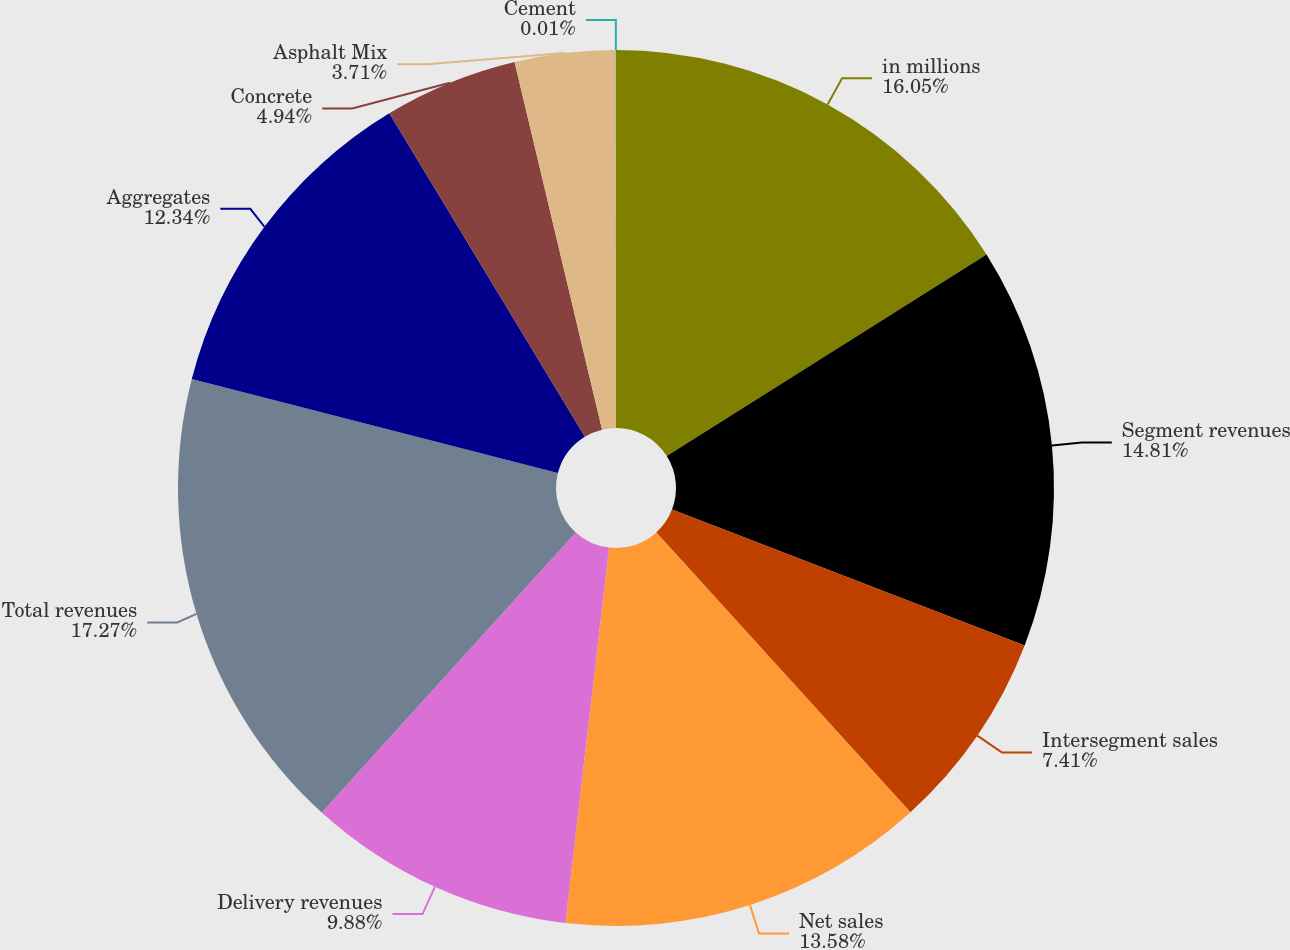<chart> <loc_0><loc_0><loc_500><loc_500><pie_chart><fcel>in millions<fcel>Segment revenues<fcel>Intersegment sales<fcel>Net sales<fcel>Delivery revenues<fcel>Total revenues<fcel>Aggregates<fcel>Concrete<fcel>Asphalt Mix<fcel>Cement<nl><fcel>16.05%<fcel>14.81%<fcel>7.41%<fcel>13.58%<fcel>9.88%<fcel>17.28%<fcel>12.34%<fcel>4.94%<fcel>3.71%<fcel>0.01%<nl></chart> 